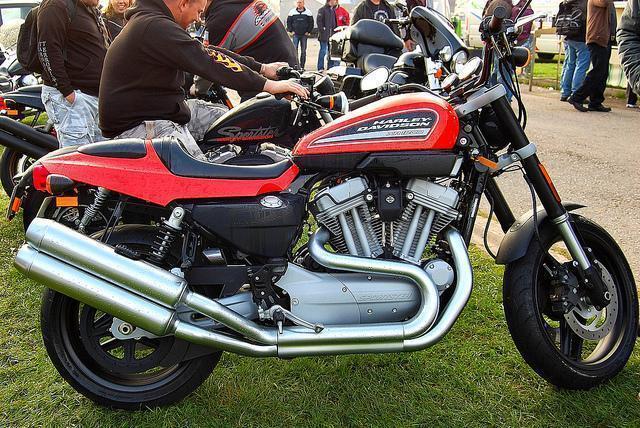What was the first name of Mr. Harley?
Indicate the correct response and explain using: 'Answer: answer
Rationale: rationale.'
Options: Sean, john, william, mark. Answer: william.
Rationale: William harley is the full name. 